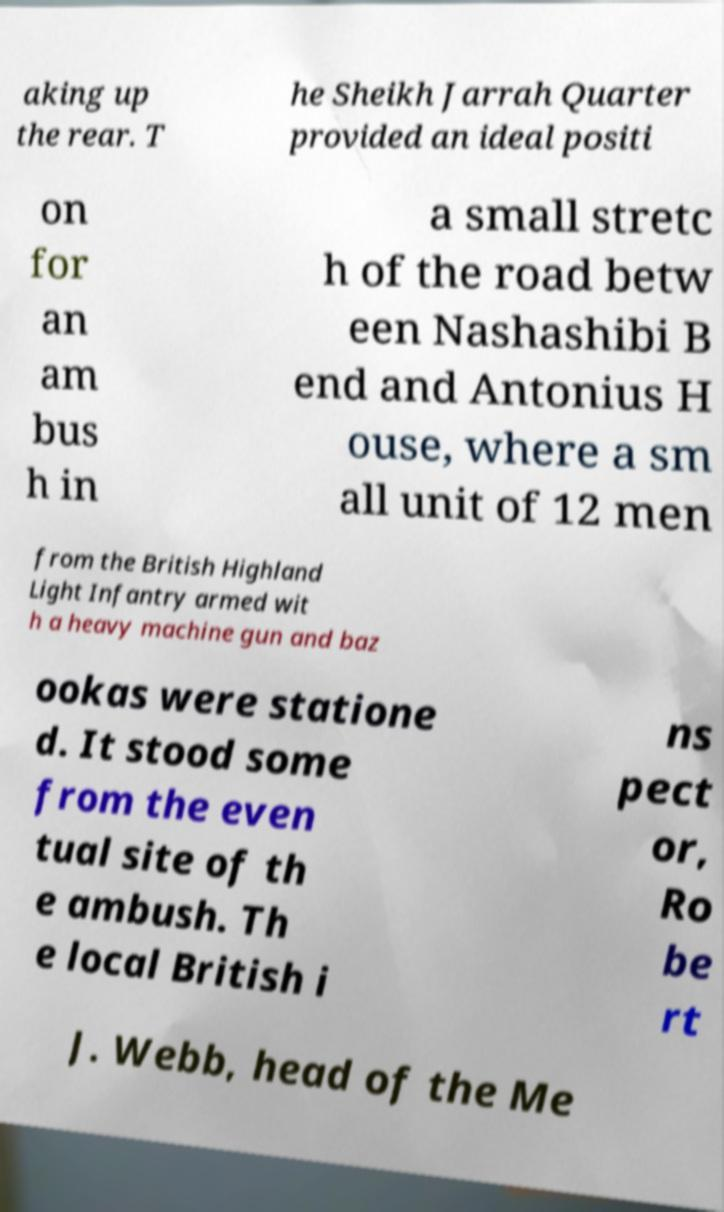What messages or text are displayed in this image? I need them in a readable, typed format. aking up the rear. T he Sheikh Jarrah Quarter provided an ideal positi on for an am bus h in a small stretc h of the road betw een Nashashibi B end and Antonius H ouse, where a sm all unit of 12 men from the British Highland Light Infantry armed wit h a heavy machine gun and baz ookas were statione d. It stood some from the even tual site of th e ambush. Th e local British i ns pect or, Ro be rt J. Webb, head of the Me 